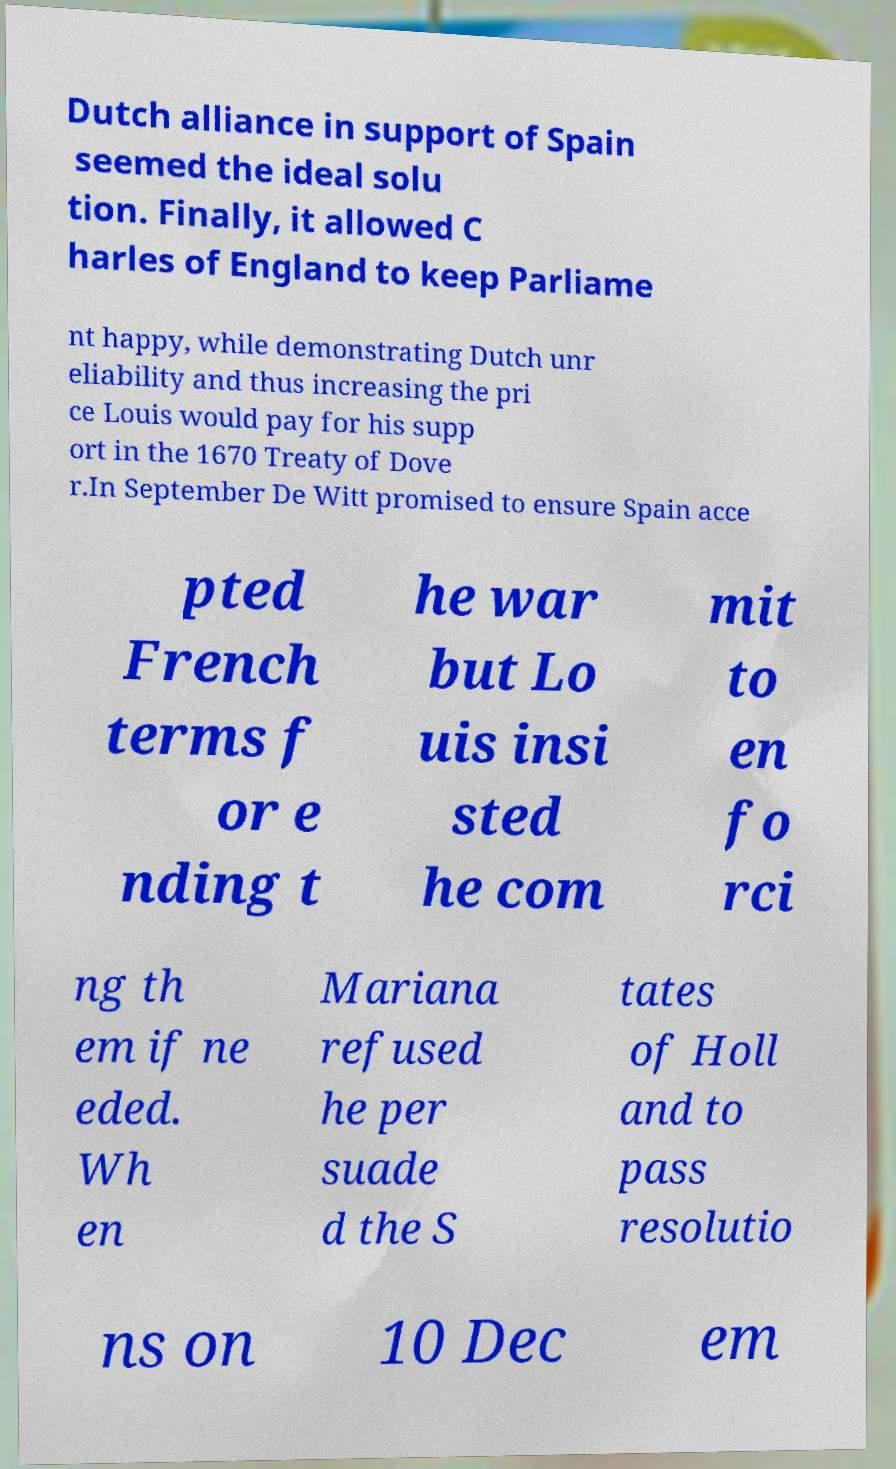Could you assist in decoding the text presented in this image and type it out clearly? Dutch alliance in support of Spain seemed the ideal solu tion. Finally, it allowed C harles of England to keep Parliame nt happy, while demonstrating Dutch unr eliability and thus increasing the pri ce Louis would pay for his supp ort in the 1670 Treaty of Dove r.In September De Witt promised to ensure Spain acce pted French terms f or e nding t he war but Lo uis insi sted he com mit to en fo rci ng th em if ne eded. Wh en Mariana refused he per suade d the S tates of Holl and to pass resolutio ns on 10 Dec em 